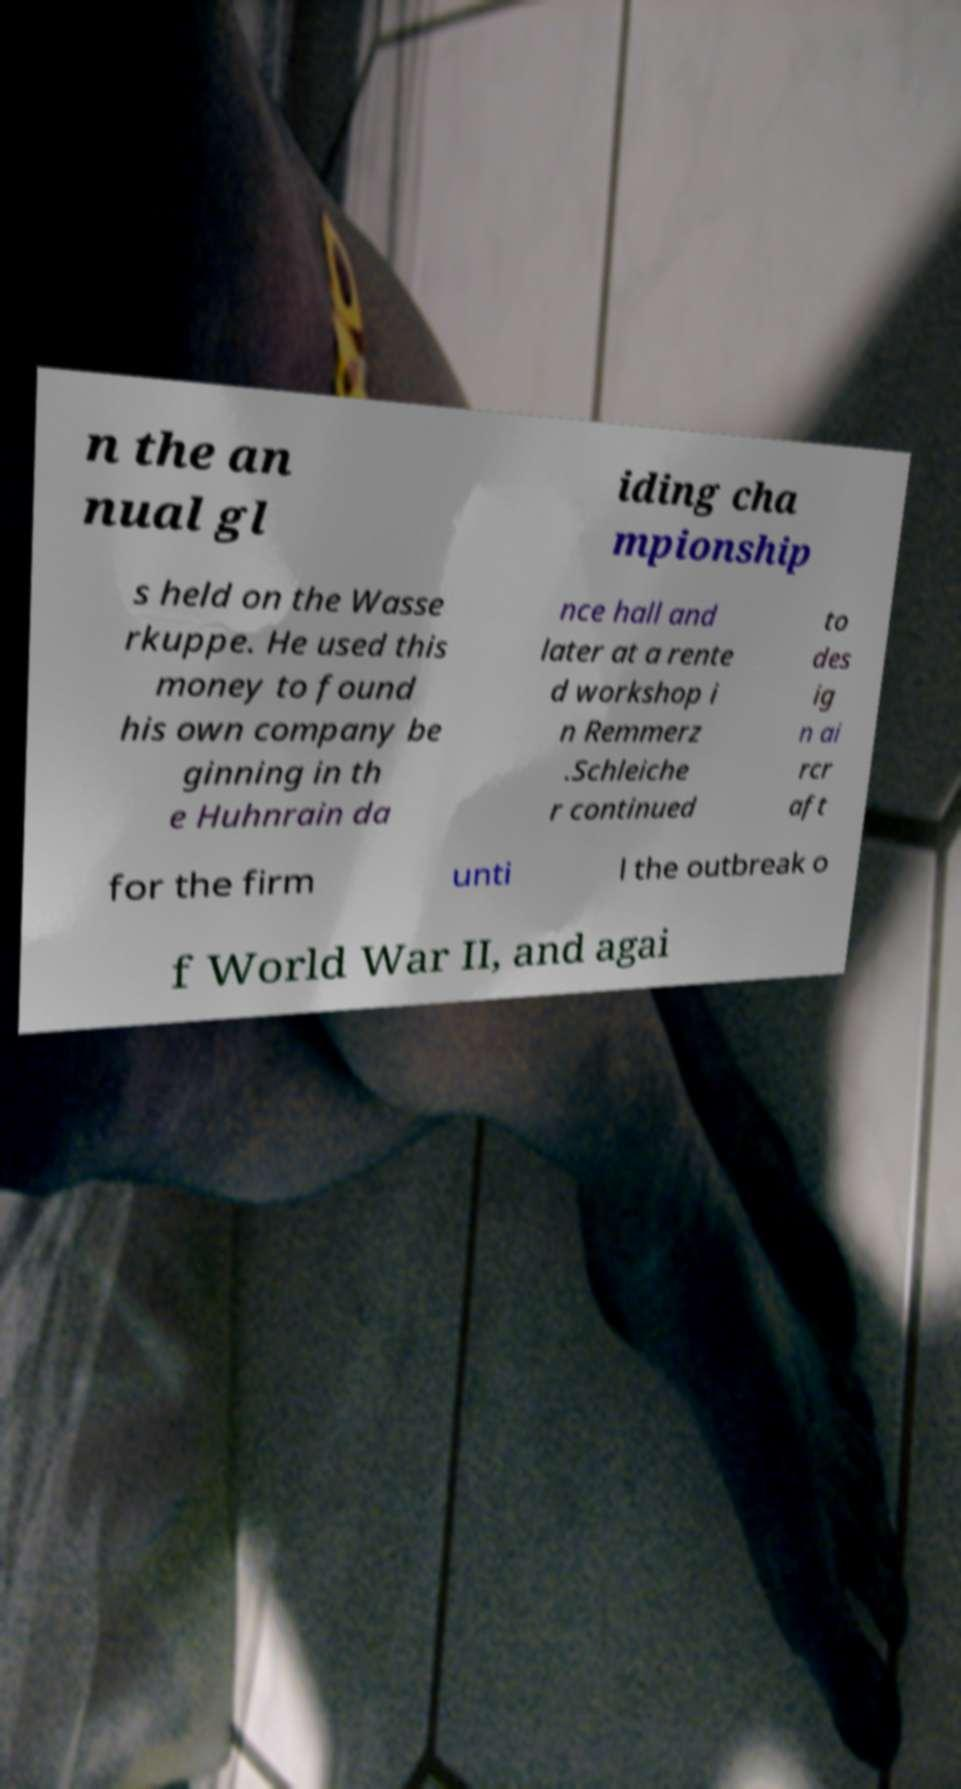For documentation purposes, I need the text within this image transcribed. Could you provide that? n the an nual gl iding cha mpionship s held on the Wasse rkuppe. He used this money to found his own company be ginning in th e Huhnrain da nce hall and later at a rente d workshop i n Remmerz .Schleiche r continued to des ig n ai rcr aft for the firm unti l the outbreak o f World War II, and agai 